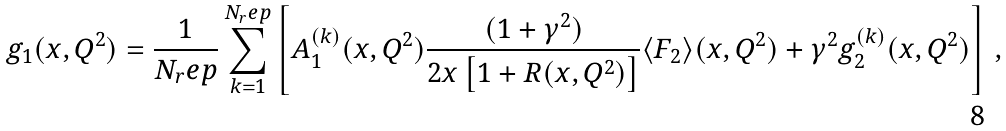<formula> <loc_0><loc_0><loc_500><loc_500>g _ { 1 } ( x , Q ^ { 2 } ) = \frac { 1 } { N _ { r } e p } \sum _ { k = 1 } ^ { N _ { r } e p } \left [ A _ { 1 } ^ { ( k ) } ( x , Q ^ { 2 } ) \frac { ( 1 + \gamma ^ { 2 } ) } { 2 x \left [ 1 + R ( x , Q ^ { 2 } ) \right ] } \langle F _ { 2 } \rangle ( x , Q ^ { 2 } ) + \gamma ^ { 2 } g _ { 2 } ^ { ( k ) } ( x , Q ^ { 2 } ) \right ] \, ,</formula> 